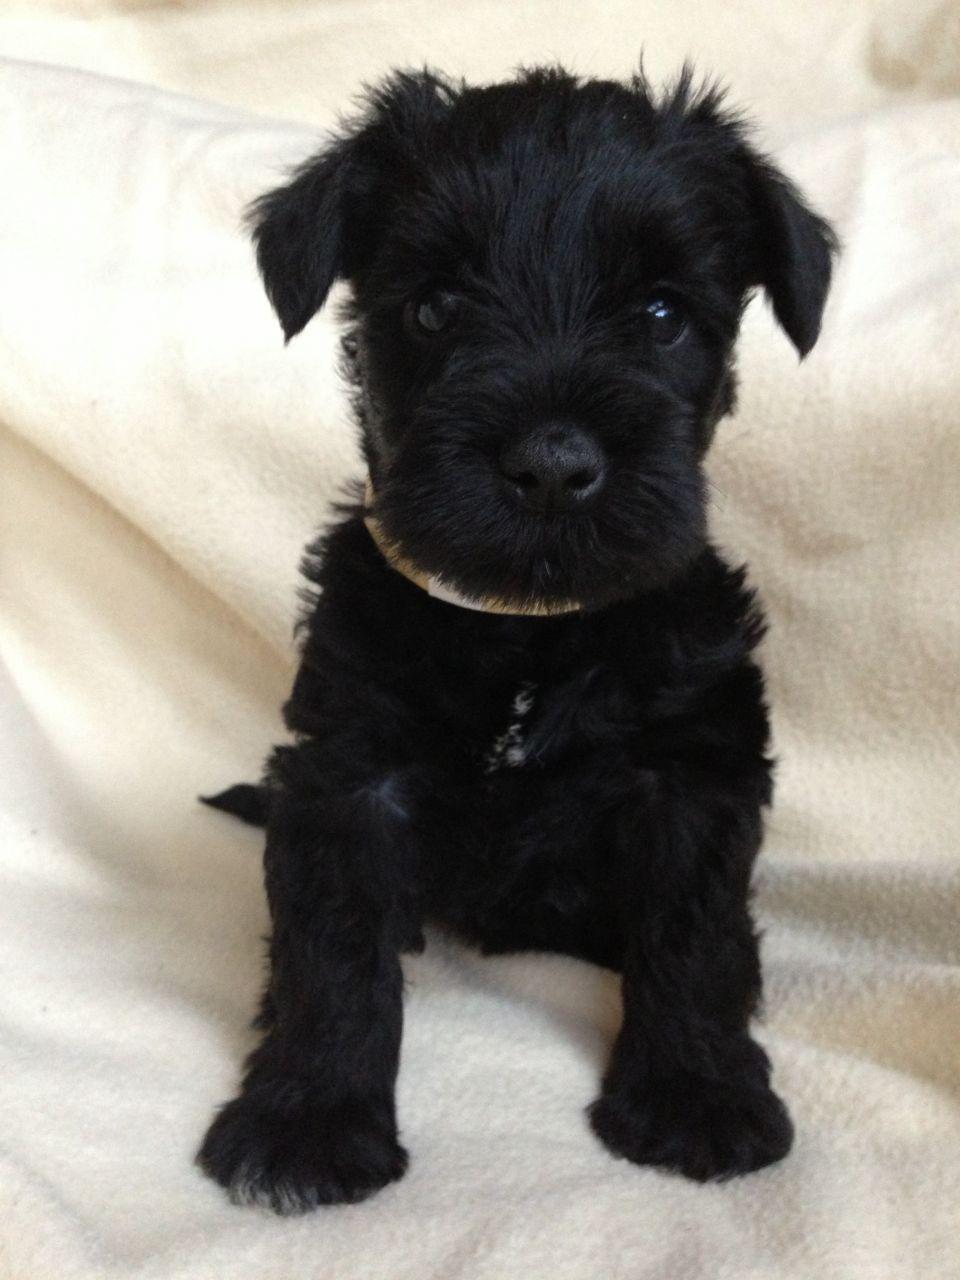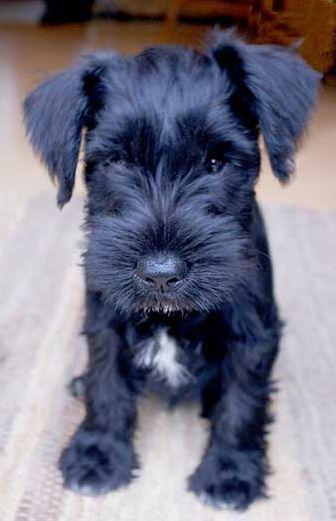The first image is the image on the left, the second image is the image on the right. For the images shown, is this caption "The puppy on the right has a white streak on its chest." true? Answer yes or no. Yes. The first image is the image on the left, the second image is the image on the right. Examine the images to the left and right. Is the description "Each image contains a camera-facing schnauzer with a solid-black face, and no image shows a dog in a reclining pose." accurate? Answer yes or no. Yes. 